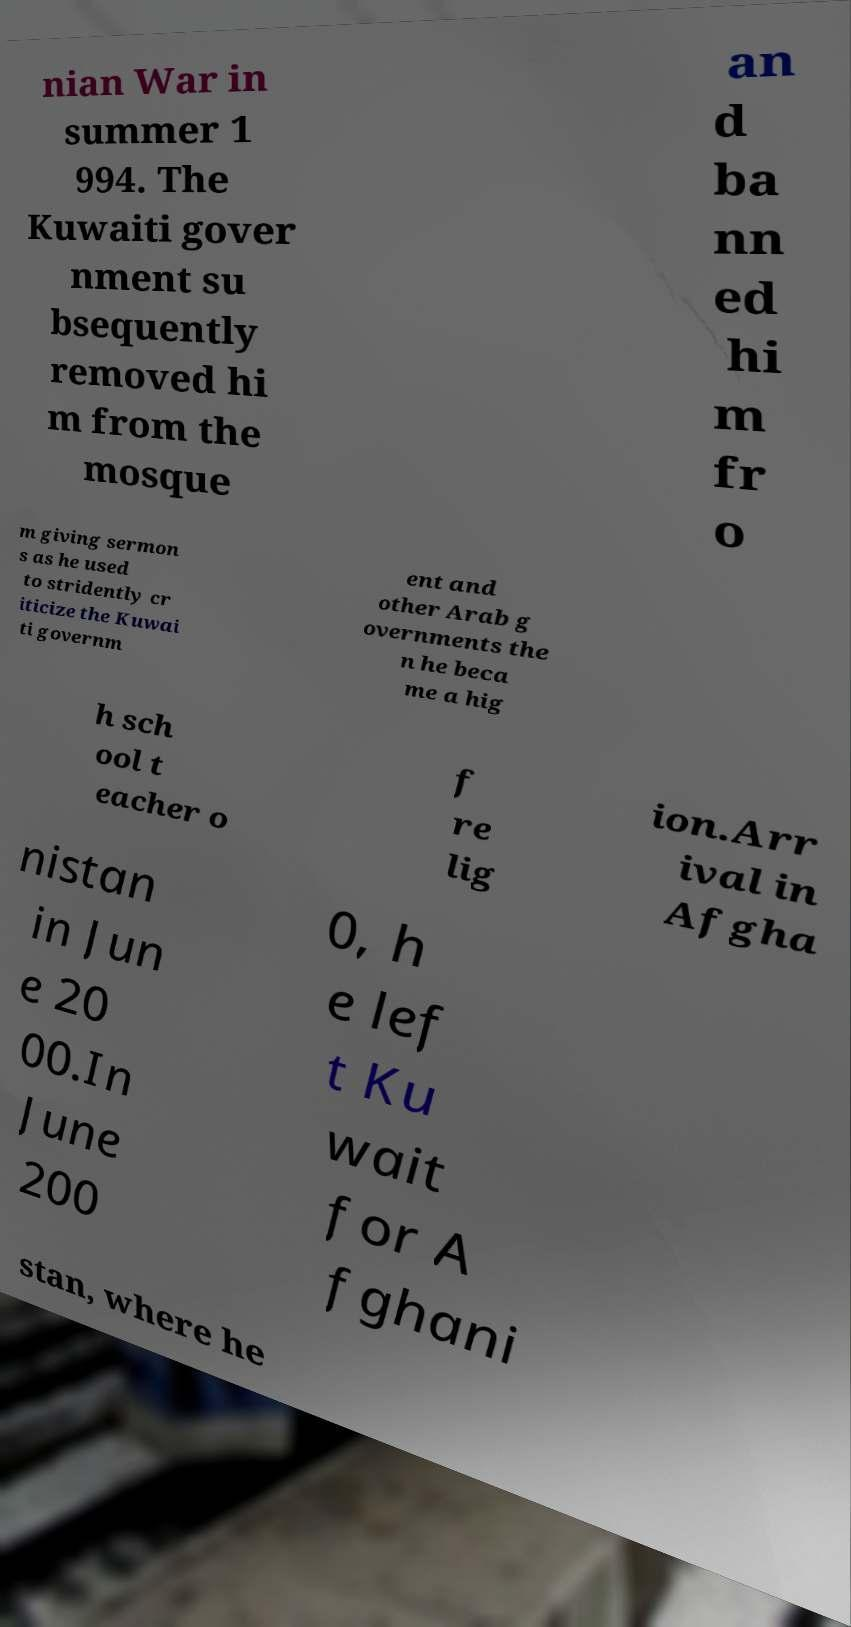There's text embedded in this image that I need extracted. Can you transcribe it verbatim? nian War in summer 1 994. The Kuwaiti gover nment su bsequently removed hi m from the mosque an d ba nn ed hi m fr o m giving sermon s as he used to stridently cr iticize the Kuwai ti governm ent and other Arab g overnments the n he beca me a hig h sch ool t eacher o f re lig ion.Arr ival in Afgha nistan in Jun e 20 00.In June 200 0, h e lef t Ku wait for A fghani stan, where he 